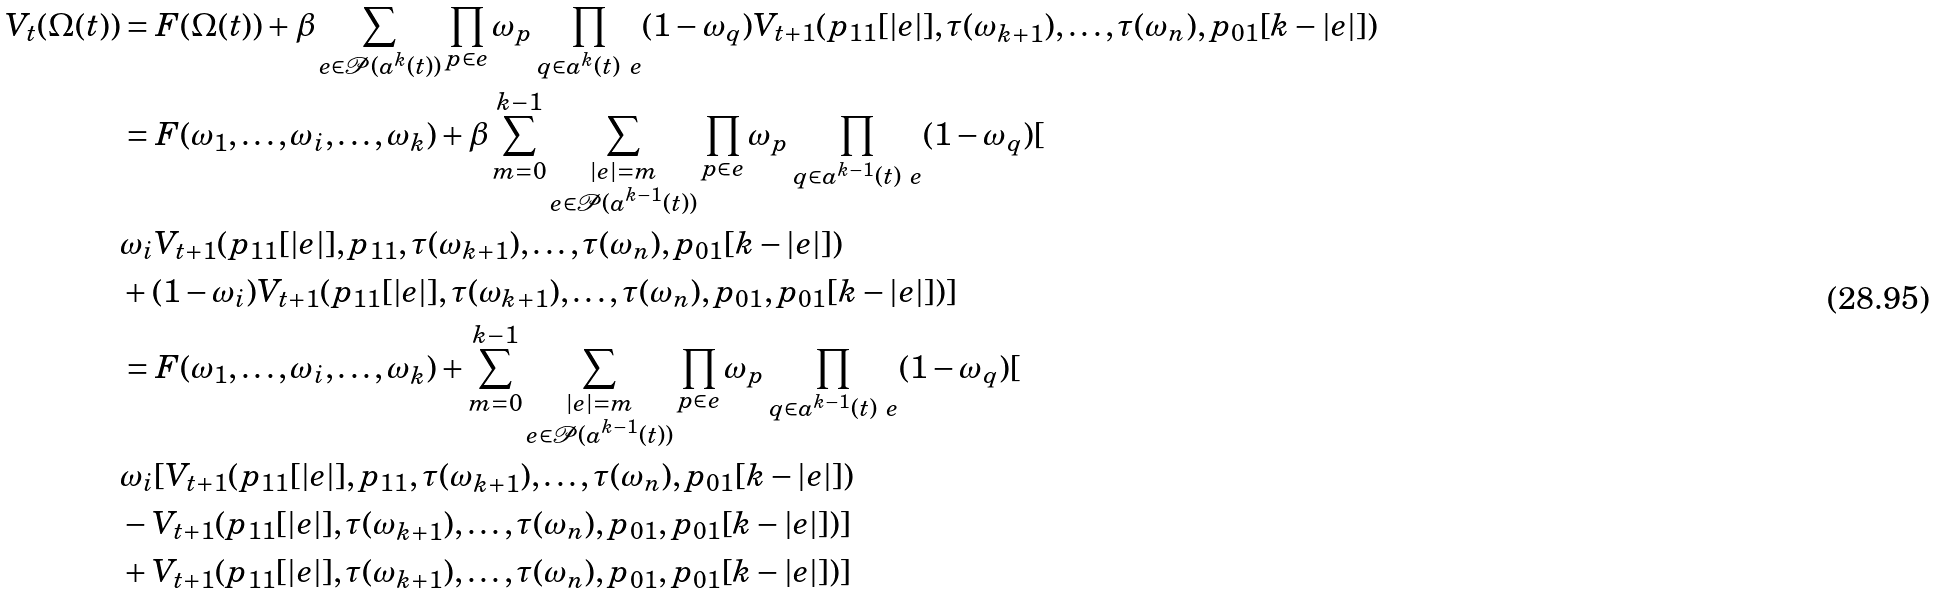Convert formula to latex. <formula><loc_0><loc_0><loc_500><loc_500>V _ { t } ( \Omega ( t ) ) & = F ( \Omega ( t ) ) + \beta \sum _ { e \in { \mathcal { P } ( a ^ { k } ( t ) ) } } \prod _ { p \in { e } } \omega _ { p } \prod _ { q \in { a ^ { k } ( t ) \ { e } } } ( 1 - \omega _ { q } ) V _ { t + 1 } ( p _ { 1 1 } [ | e | ] , \tau ( { \omega _ { k + 1 } } ) , \dots , \tau ( { \omega _ { n } } ) , p _ { 0 1 } [ k - | e | ] ) \\ & = F ( \omega _ { 1 } , \dots , \omega _ { i } , \dots , \omega _ { k } ) + \beta \sum _ { m = 0 } ^ { k - 1 } \sum _ { \substack { | e | = m \\ e \in { \mathcal { P } ( a ^ { k - 1 } ( t ) ) } } } \prod _ { p \in { e } } \omega _ { p } \prod _ { q \in { a ^ { k - 1 } ( t ) \ { e } } } ( 1 - \omega _ { q } ) [ \\ & \omega _ { i } V _ { t + 1 } ( p _ { 1 1 } [ | e | ] , p _ { 1 1 } , \tau ( { \omega _ { k + 1 } } ) , \dots , \tau ( { \omega _ { n } } ) , p _ { 0 1 } [ k - | e | ] ) \\ & + ( 1 - \omega _ { i } ) V _ { t + 1 } ( p _ { 1 1 } [ | e | ] , \tau ( { \omega _ { k + 1 } } ) , \dots , \tau ( { \omega _ { n } } ) , p _ { 0 1 } , p _ { 0 1 } [ k - | e | ] ) ] \\ & = F ( \omega _ { 1 } , \dots , \omega _ { i } , \dots , \omega _ { k } ) + \sum _ { m = 0 } ^ { k - 1 } \sum _ { \substack { | e | = m \\ e \in { \mathcal { P } ( a ^ { k - 1 } ( t ) ) } } } \prod _ { p \in { e } } \omega _ { p } \prod _ { q \in { a ^ { k - 1 } ( t ) \ { e } } } ( 1 - \omega _ { q } ) [ \\ & \omega _ { i } [ V _ { t + 1 } ( p _ { 1 1 } [ | e | ] , p _ { 1 1 } , \tau ( { \omega _ { k + 1 } } ) , \dots , \tau ( { \omega _ { n } } ) , p _ { 0 1 } [ k - | e | ] ) \\ & - V _ { t + 1 } ( p _ { 1 1 } [ | e | ] , \tau ( { \omega _ { k + 1 } } ) , \dots , \tau ( { \omega _ { n } } ) , p _ { 0 1 } , p _ { 0 1 } [ k - | e | ] ) ] \\ & + V _ { t + 1 } ( p _ { 1 1 } [ | e | ] , \tau ( { \omega _ { k + 1 } } ) , \dots , \tau ( { \omega _ { n } } ) , p _ { 0 1 } , p _ { 0 1 } [ k - | e | ] ) ]</formula> 